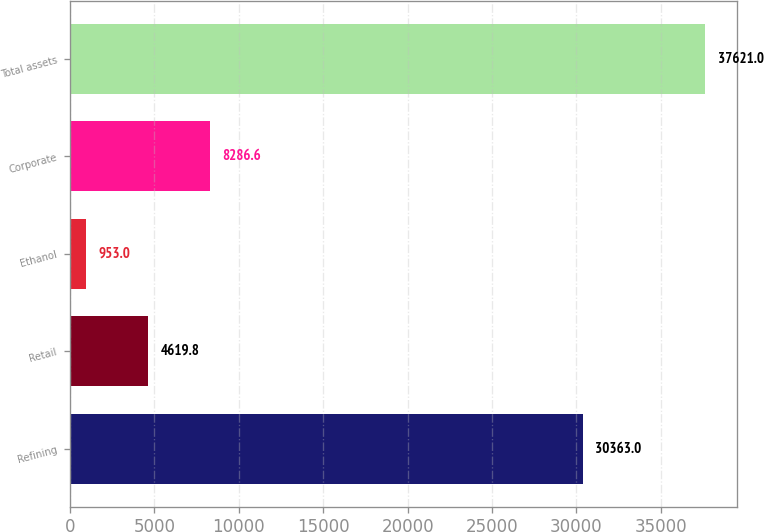<chart> <loc_0><loc_0><loc_500><loc_500><bar_chart><fcel>Refining<fcel>Retail<fcel>Ethanol<fcel>Corporate<fcel>Total assets<nl><fcel>30363<fcel>4619.8<fcel>953<fcel>8286.6<fcel>37621<nl></chart> 